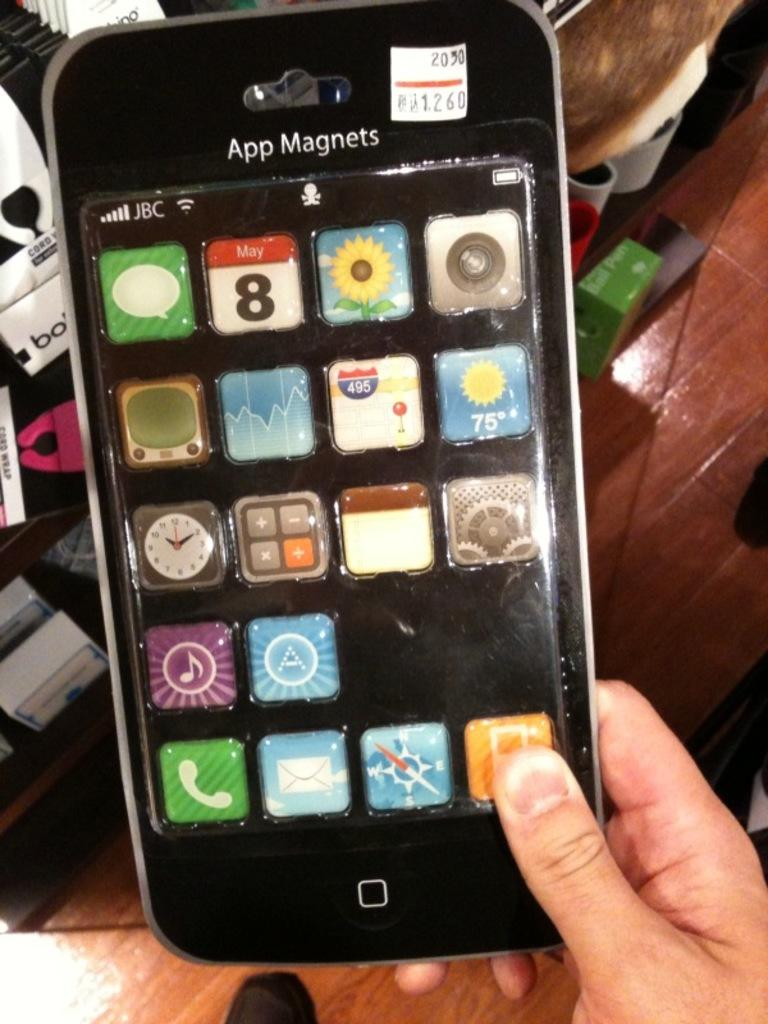<image>
Provide a brief description of the given image. A person is holding a package of magnets shaped like an iPhone that says App Magnets. 